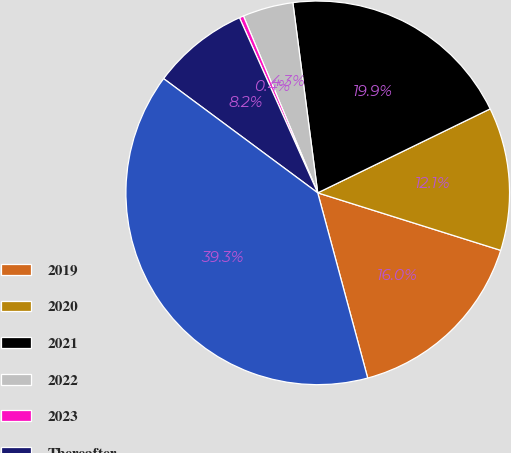Convert chart. <chart><loc_0><loc_0><loc_500><loc_500><pie_chart><fcel>2019<fcel>2020<fcel>2021<fcel>2022<fcel>2023<fcel>Thereafter<fcel>Total Outstanding<nl><fcel>15.96%<fcel>12.06%<fcel>19.86%<fcel>4.26%<fcel>0.36%<fcel>8.16%<fcel>39.35%<nl></chart> 